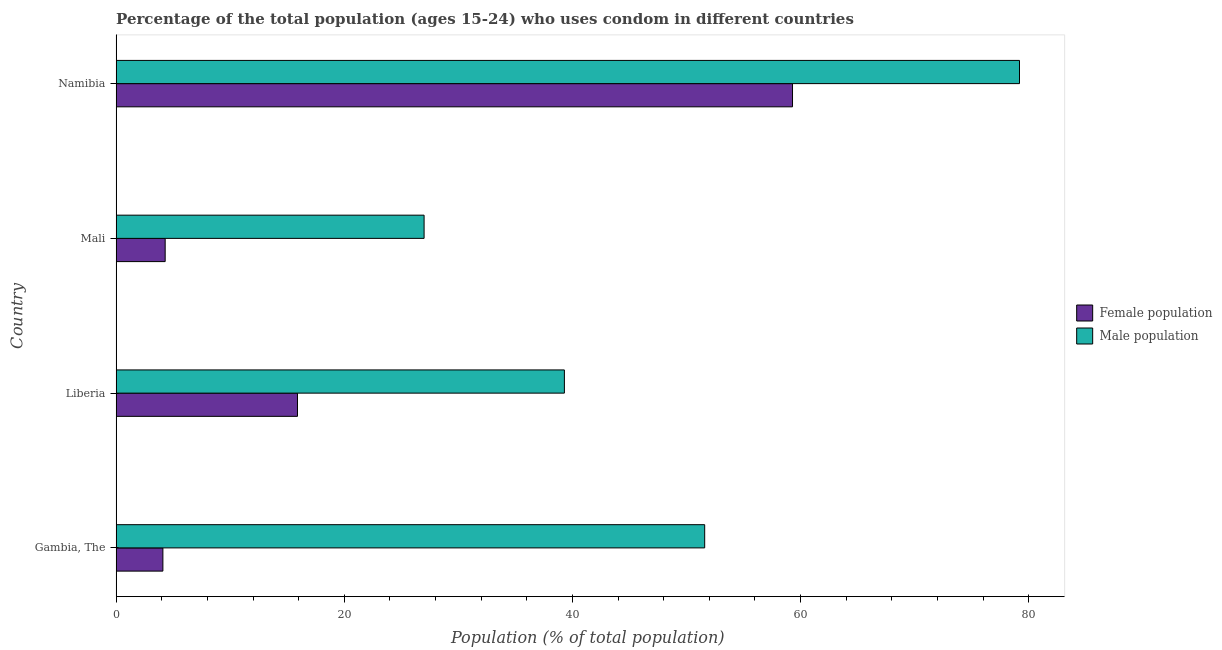How many groups of bars are there?
Ensure brevity in your answer.  4. What is the label of the 1st group of bars from the top?
Your answer should be very brief. Namibia. What is the female population in Mali?
Provide a short and direct response. 4.3. Across all countries, what is the maximum female population?
Provide a short and direct response. 59.3. In which country was the male population maximum?
Give a very brief answer. Namibia. In which country was the male population minimum?
Your answer should be compact. Mali. What is the total female population in the graph?
Provide a succinct answer. 83.6. What is the difference between the male population in Liberia and that in Namibia?
Give a very brief answer. -39.9. What is the difference between the female population in Mali and the male population in Namibia?
Provide a succinct answer. -74.9. What is the average female population per country?
Your answer should be very brief. 20.9. In how many countries, is the female population greater than 24 %?
Your response must be concise. 1. What is the ratio of the female population in Gambia, The to that in Liberia?
Your answer should be compact. 0.26. Is the difference between the male population in Liberia and Namibia greater than the difference between the female population in Liberia and Namibia?
Give a very brief answer. Yes. What is the difference between the highest and the second highest female population?
Your response must be concise. 43.4. What is the difference between the highest and the lowest female population?
Provide a succinct answer. 55.2. In how many countries, is the female population greater than the average female population taken over all countries?
Ensure brevity in your answer.  1. Is the sum of the male population in Gambia, The and Namibia greater than the maximum female population across all countries?
Keep it short and to the point. Yes. What does the 1st bar from the top in Namibia represents?
Provide a short and direct response. Male population. What does the 2nd bar from the bottom in Namibia represents?
Your answer should be compact. Male population. How many bars are there?
Your response must be concise. 8. Are all the bars in the graph horizontal?
Give a very brief answer. Yes. How many legend labels are there?
Provide a short and direct response. 2. What is the title of the graph?
Offer a terse response. Percentage of the total population (ages 15-24) who uses condom in different countries. What is the label or title of the X-axis?
Your answer should be very brief. Population (% of total population) . What is the label or title of the Y-axis?
Provide a short and direct response. Country. What is the Population (% of total population)  in Female population in Gambia, The?
Provide a succinct answer. 4.1. What is the Population (% of total population)  of Male population in Gambia, The?
Provide a short and direct response. 51.6. What is the Population (% of total population)  of Male population in Liberia?
Keep it short and to the point. 39.3. What is the Population (% of total population)  of Male population in Mali?
Offer a very short reply. 27. What is the Population (% of total population)  in Female population in Namibia?
Your answer should be compact. 59.3. What is the Population (% of total population)  in Male population in Namibia?
Ensure brevity in your answer.  79.2. Across all countries, what is the maximum Population (% of total population)  of Female population?
Make the answer very short. 59.3. Across all countries, what is the maximum Population (% of total population)  of Male population?
Offer a very short reply. 79.2. Across all countries, what is the minimum Population (% of total population)  in Female population?
Offer a terse response. 4.1. What is the total Population (% of total population)  in Female population in the graph?
Offer a terse response. 83.6. What is the total Population (% of total population)  in Male population in the graph?
Your answer should be very brief. 197.1. What is the difference between the Population (% of total population)  in Female population in Gambia, The and that in Liberia?
Your response must be concise. -11.8. What is the difference between the Population (% of total population)  in Male population in Gambia, The and that in Liberia?
Ensure brevity in your answer.  12.3. What is the difference between the Population (% of total population)  in Female population in Gambia, The and that in Mali?
Provide a succinct answer. -0.2. What is the difference between the Population (% of total population)  in Male population in Gambia, The and that in Mali?
Give a very brief answer. 24.6. What is the difference between the Population (% of total population)  in Female population in Gambia, The and that in Namibia?
Your answer should be compact. -55.2. What is the difference between the Population (% of total population)  in Male population in Gambia, The and that in Namibia?
Your answer should be very brief. -27.6. What is the difference between the Population (% of total population)  in Female population in Liberia and that in Namibia?
Offer a terse response. -43.4. What is the difference between the Population (% of total population)  of Male population in Liberia and that in Namibia?
Ensure brevity in your answer.  -39.9. What is the difference between the Population (% of total population)  of Female population in Mali and that in Namibia?
Your answer should be compact. -55. What is the difference between the Population (% of total population)  in Male population in Mali and that in Namibia?
Your response must be concise. -52.2. What is the difference between the Population (% of total population)  in Female population in Gambia, The and the Population (% of total population)  in Male population in Liberia?
Provide a short and direct response. -35.2. What is the difference between the Population (% of total population)  in Female population in Gambia, The and the Population (% of total population)  in Male population in Mali?
Provide a short and direct response. -22.9. What is the difference between the Population (% of total population)  of Female population in Gambia, The and the Population (% of total population)  of Male population in Namibia?
Give a very brief answer. -75.1. What is the difference between the Population (% of total population)  in Female population in Liberia and the Population (% of total population)  in Male population in Mali?
Ensure brevity in your answer.  -11.1. What is the difference between the Population (% of total population)  in Female population in Liberia and the Population (% of total population)  in Male population in Namibia?
Provide a short and direct response. -63.3. What is the difference between the Population (% of total population)  of Female population in Mali and the Population (% of total population)  of Male population in Namibia?
Your answer should be compact. -74.9. What is the average Population (% of total population)  in Female population per country?
Keep it short and to the point. 20.9. What is the average Population (% of total population)  of Male population per country?
Offer a very short reply. 49.27. What is the difference between the Population (% of total population)  of Female population and Population (% of total population)  of Male population in Gambia, The?
Offer a terse response. -47.5. What is the difference between the Population (% of total population)  in Female population and Population (% of total population)  in Male population in Liberia?
Offer a very short reply. -23.4. What is the difference between the Population (% of total population)  in Female population and Population (% of total population)  in Male population in Mali?
Provide a short and direct response. -22.7. What is the difference between the Population (% of total population)  of Female population and Population (% of total population)  of Male population in Namibia?
Your answer should be very brief. -19.9. What is the ratio of the Population (% of total population)  of Female population in Gambia, The to that in Liberia?
Offer a terse response. 0.26. What is the ratio of the Population (% of total population)  in Male population in Gambia, The to that in Liberia?
Provide a succinct answer. 1.31. What is the ratio of the Population (% of total population)  of Female population in Gambia, The to that in Mali?
Your answer should be very brief. 0.95. What is the ratio of the Population (% of total population)  in Male population in Gambia, The to that in Mali?
Keep it short and to the point. 1.91. What is the ratio of the Population (% of total population)  of Female population in Gambia, The to that in Namibia?
Make the answer very short. 0.07. What is the ratio of the Population (% of total population)  of Male population in Gambia, The to that in Namibia?
Your response must be concise. 0.65. What is the ratio of the Population (% of total population)  in Female population in Liberia to that in Mali?
Provide a short and direct response. 3.7. What is the ratio of the Population (% of total population)  in Male population in Liberia to that in Mali?
Your response must be concise. 1.46. What is the ratio of the Population (% of total population)  in Female population in Liberia to that in Namibia?
Offer a terse response. 0.27. What is the ratio of the Population (% of total population)  in Male population in Liberia to that in Namibia?
Make the answer very short. 0.5. What is the ratio of the Population (% of total population)  of Female population in Mali to that in Namibia?
Your answer should be compact. 0.07. What is the ratio of the Population (% of total population)  in Male population in Mali to that in Namibia?
Your response must be concise. 0.34. What is the difference between the highest and the second highest Population (% of total population)  of Female population?
Provide a short and direct response. 43.4. What is the difference between the highest and the second highest Population (% of total population)  of Male population?
Ensure brevity in your answer.  27.6. What is the difference between the highest and the lowest Population (% of total population)  in Female population?
Make the answer very short. 55.2. What is the difference between the highest and the lowest Population (% of total population)  of Male population?
Your answer should be very brief. 52.2. 